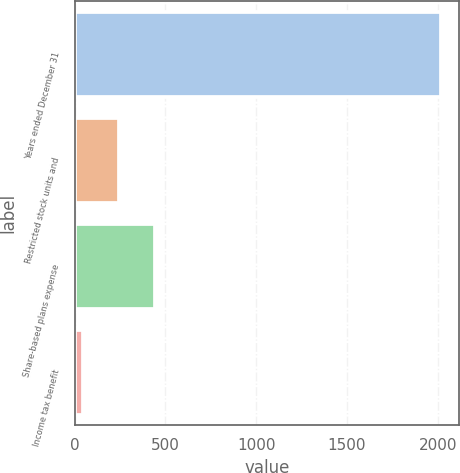Convert chart. <chart><loc_0><loc_0><loc_500><loc_500><bar_chart><fcel>Years ended December 31<fcel>Restricted stock units and<fcel>Share-based plans expense<fcel>Income tax benefit<nl><fcel>2018<fcel>243.2<fcel>440.4<fcel>46<nl></chart> 